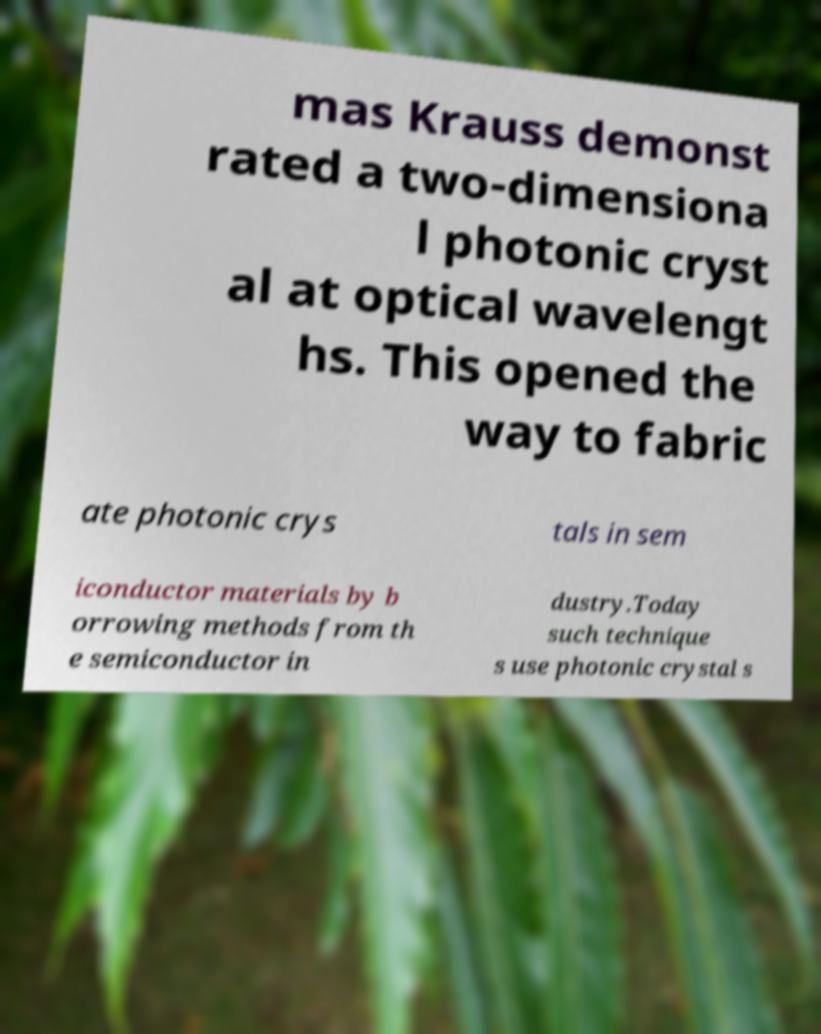Can you accurately transcribe the text from the provided image for me? mas Krauss demonst rated a two-dimensiona l photonic cryst al at optical wavelengt hs. This opened the way to fabric ate photonic crys tals in sem iconductor materials by b orrowing methods from th e semiconductor in dustry.Today such technique s use photonic crystal s 